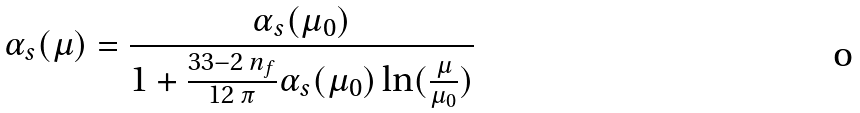<formula> <loc_0><loc_0><loc_500><loc_500>\alpha _ { s } ( \mu ) = \frac { \alpha _ { s } ( \mu _ { 0 } ) } { 1 + \frac { 3 3 - 2 \, n _ { f } } { 1 2 \, \pi } \alpha _ { s } ( \mu _ { 0 } ) \ln ( \frac { \mu } { \mu _ { 0 } } ) }</formula> 